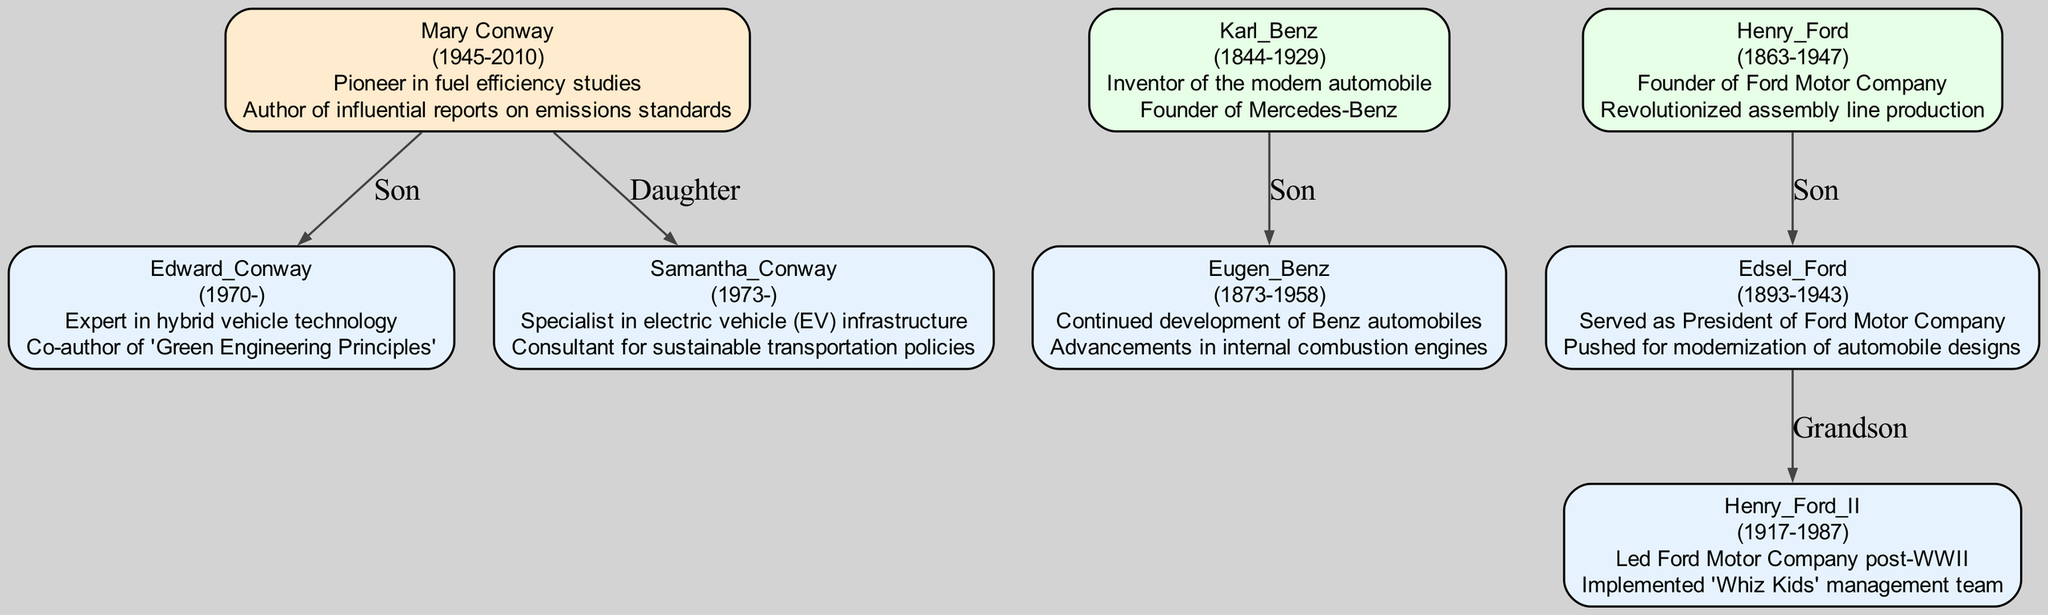What is the birth year of Mary Conway? According to the diagram, Mary Conway was born in 1945. This information is found directly under her name in the corresponding box.
Answer: 1945 How many descendants does Karl Benz have? In the diagram, Karl Benz has one descendant (Eugen Benz), as indicated in the family tree structure that branches out from his node.
Answer: 1 What contributions did Edward Conway make? The contributions listed for Edward Conway in the diagram include "Expert in hybrid vehicle technology" and "Co-author of 'Green Engineering Principles'." These are provided in his corresponding node.
Answer: Expert in hybrid vehicle technology, Co-author of 'Green Engineering Principles' What is the relationship between Henry Ford and Henry Ford II? In the family tree, Henry Ford is the grandfather of Henry Ford II. This relationship is indicated by the positioning in the diagram and the labels on the connecting edges.
Answer: Grandfather Who founded the Ford Motor Company? The diagram states that Henry Ford was the founder of the Ford Motor Company, as this contribution is highlighted under his name in the family tree.
Answer: Henry Ford Which descendant of Mary Conway is a daughter? The diagram specifies that Samantha Conway, born in 1973, is the daughter of Mary Conway. This is shown in the branching structure under Mary Conway's node.
Answer: Samantha Conway What profession is associated with Samantha Conway? According to the diagram, Samantha Conway is a specialist in electric vehicle (EV) infrastructure, detailed in her contribution section within her node.
Answer: Specialist in electric vehicle (EV) infrastructure Who are the immediate descendants of Henry Ford? The diagram shows that Edsel Ford is the immediate descendant of Henry Ford, as he is the only one listed directly under Henry Ford in the family tree.
Answer: Edsel Ford What significant role did Edsel Ford hold? In the diagram, it is noted that Edsel Ford served as President of Ford Motor Company, which is one of the contributions mentioned in his node.
Answer: President of Ford Motor Company 